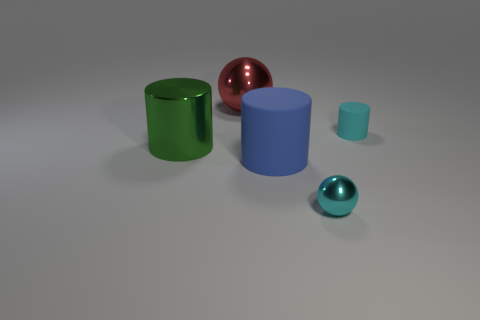Subtract all rubber cylinders. How many cylinders are left? 1 Add 3 cyan rubber cubes. How many objects exist? 8 Subtract all cylinders. How many objects are left? 2 Add 1 large green things. How many large green things exist? 2 Subtract 0 blue cubes. How many objects are left? 5 Subtract all big blue matte cylinders. Subtract all tiny spheres. How many objects are left? 3 Add 3 red balls. How many red balls are left? 4 